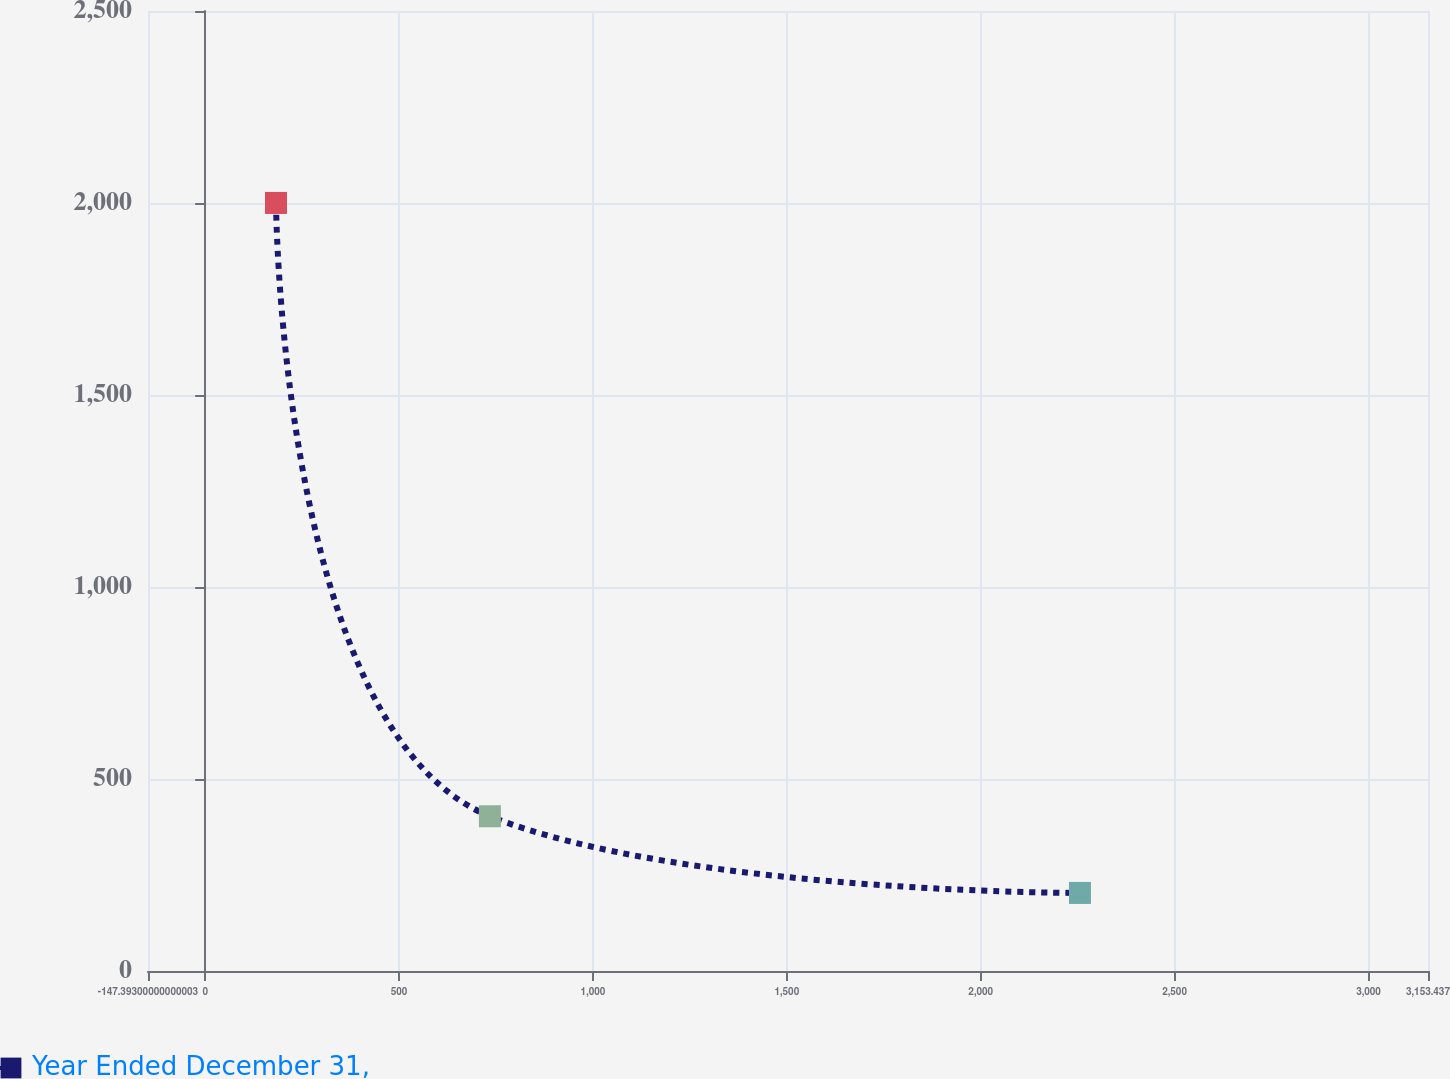Convert chart to OTSL. <chart><loc_0><loc_0><loc_500><loc_500><line_chart><ecel><fcel>Year Ended December 31,<nl><fcel>182.69<fcel>2000.17<nl><fcel>734.29<fcel>402.94<nl><fcel>2255.92<fcel>203.28<nl><fcel>3483.52<fcel>3.62<nl></chart> 